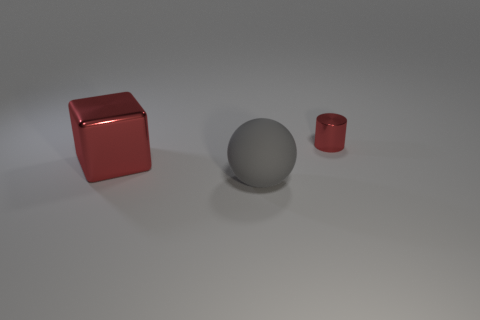There is a tiny cylinder that is the same color as the large cube; what is it made of?
Offer a terse response. Metal. How many other objects are there of the same color as the big block?
Make the answer very short. 1. The big object that is made of the same material as the cylinder is what shape?
Provide a short and direct response. Cube. Is the number of gray balls that are to the right of the gray matte sphere less than the number of big balls on the left side of the large shiny thing?
Your answer should be very brief. No. Is the number of tiny cylinders greater than the number of tiny gray cylinders?
Provide a short and direct response. Yes. What is the material of the ball?
Provide a short and direct response. Rubber. There is a shiny object that is left of the large rubber object; what is its color?
Keep it short and to the point. Red. Is the number of red metal objects that are in front of the small red metal thing greater than the number of matte things that are left of the matte ball?
Offer a terse response. Yes. There is a red shiny object that is right of the large thing in front of the red metal object to the left of the small red metallic object; what is its size?
Provide a succinct answer. Small. Is there another shiny object of the same color as the big metallic thing?
Make the answer very short. Yes. 